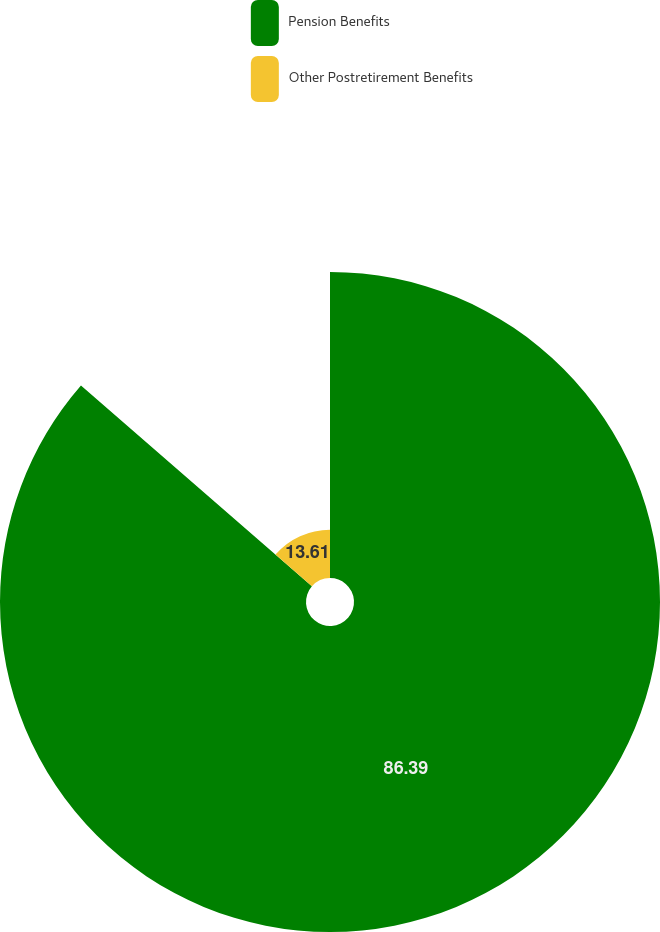Convert chart to OTSL. <chart><loc_0><loc_0><loc_500><loc_500><pie_chart><fcel>Pension Benefits<fcel>Other Postretirement Benefits<nl><fcel>86.39%<fcel>13.61%<nl></chart> 